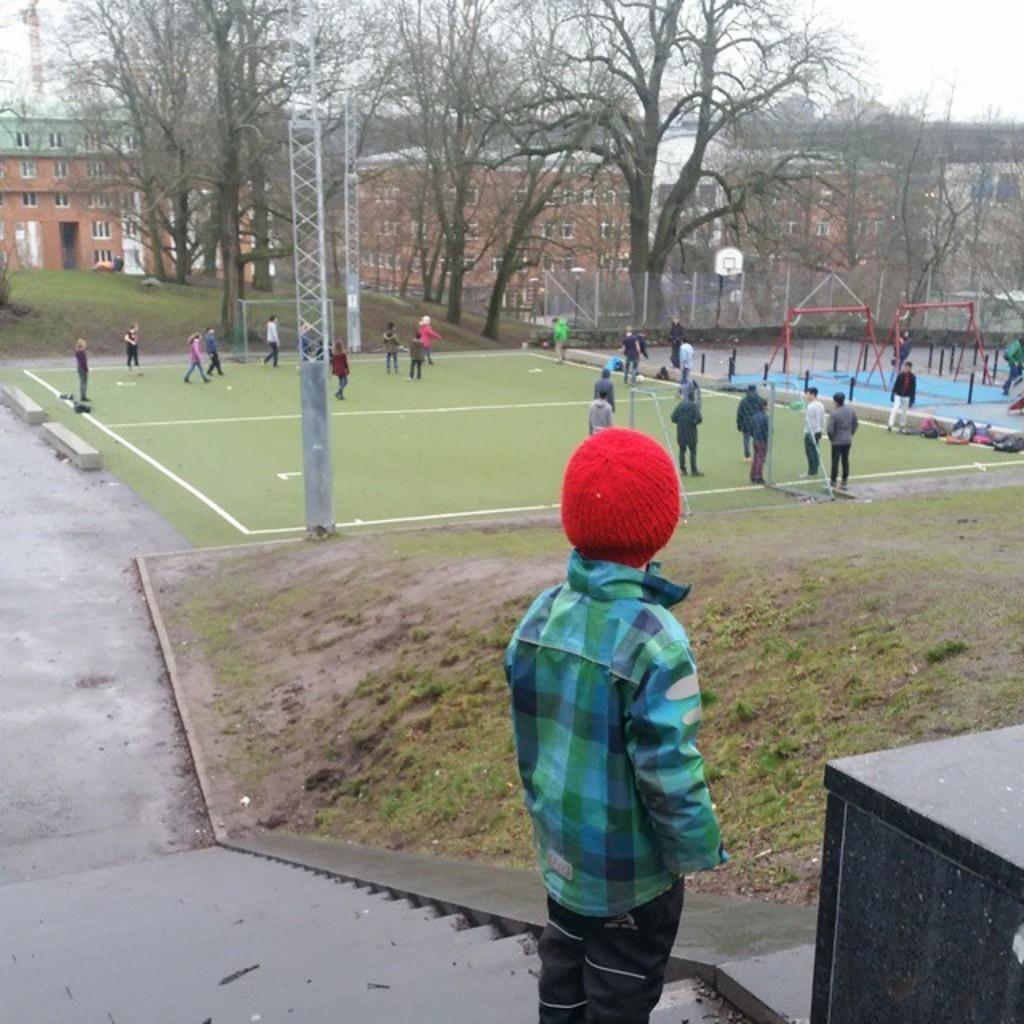What is the most prominent feature of the person in the image? The person in the image is wearing a red cap. What type of structures can be seen in the image? There are buildings in the image. What other natural elements are present in the image? There are trees in the image. What man-made objects can be seen in the image? There are poles in the image. How many people are visible in the image? There are other people in the image besides the person wearing the red cap. What letters are being used to play chess in the image? There is no chess game or letters present in the image. 